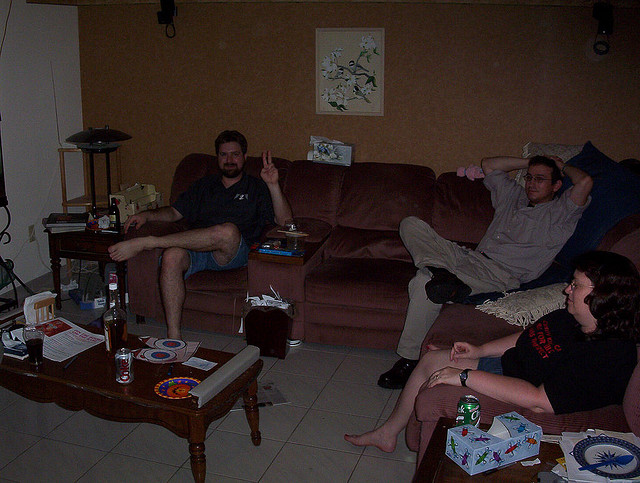Read and extract the text from this image. Coke 